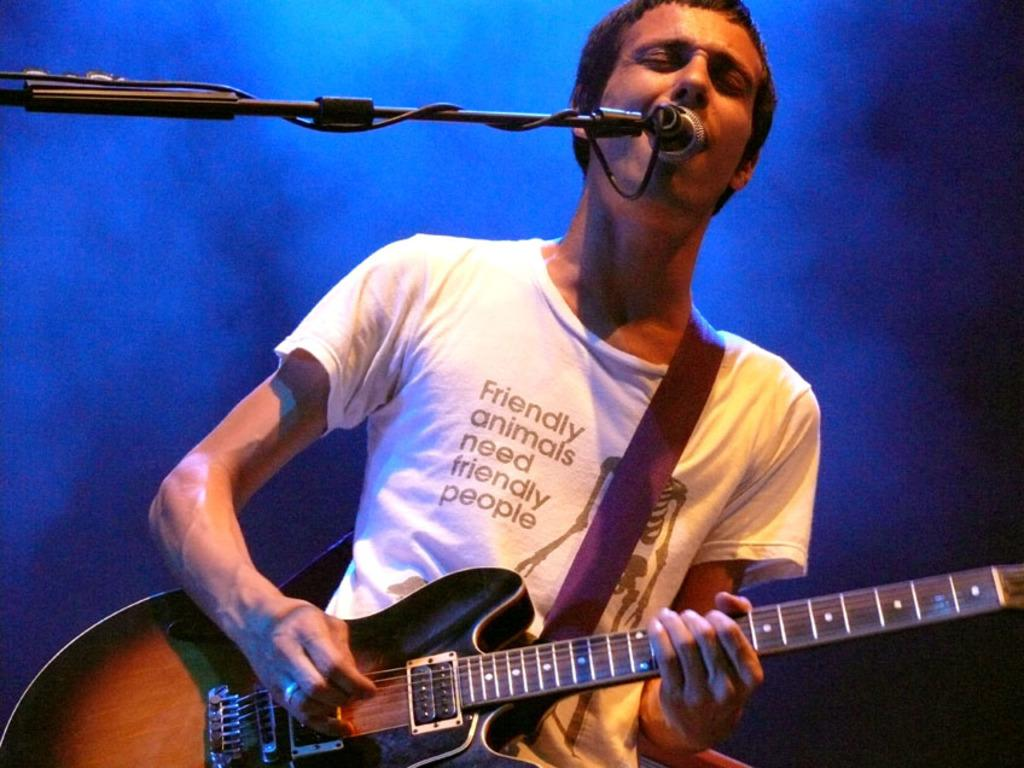What is the main subject of the image? There is a person in the image. What is the person wearing? The person is wearing a white T-shirt. What activity is the person engaged in? The person is playing a guitar. What object is visible at the top of the image? There is a microphone at the top of the image. Is the person in the image stuck in quicksand while playing the guitar? There is no indication of quicksand in the image; the person is playing the guitar while standing on a solid surface. 